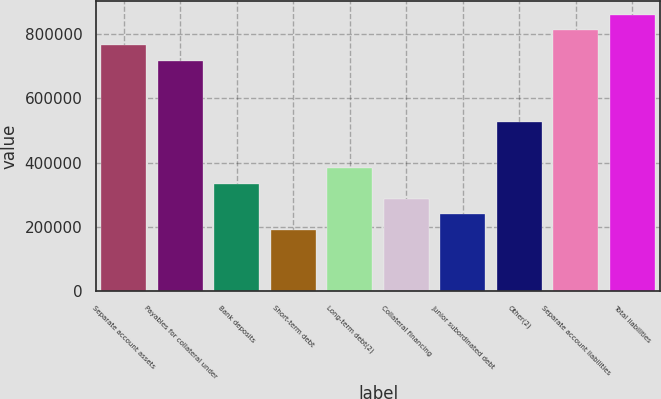Convert chart. <chart><loc_0><loc_0><loc_500><loc_500><bar_chart><fcel>Separate account assets<fcel>Payables for collateral under<fcel>Bank deposits<fcel>Short-term debt<fcel>Long-term debt(2)<fcel>Collateral financing<fcel>Junior subordinated debt<fcel>Other(2)<fcel>Separate account liabilities<fcel>Total liabilities<nl><fcel>764308<fcel>716539<fcel>334385<fcel>191078<fcel>382155<fcel>286616<fcel>238847<fcel>525462<fcel>812077<fcel>859847<nl></chart> 